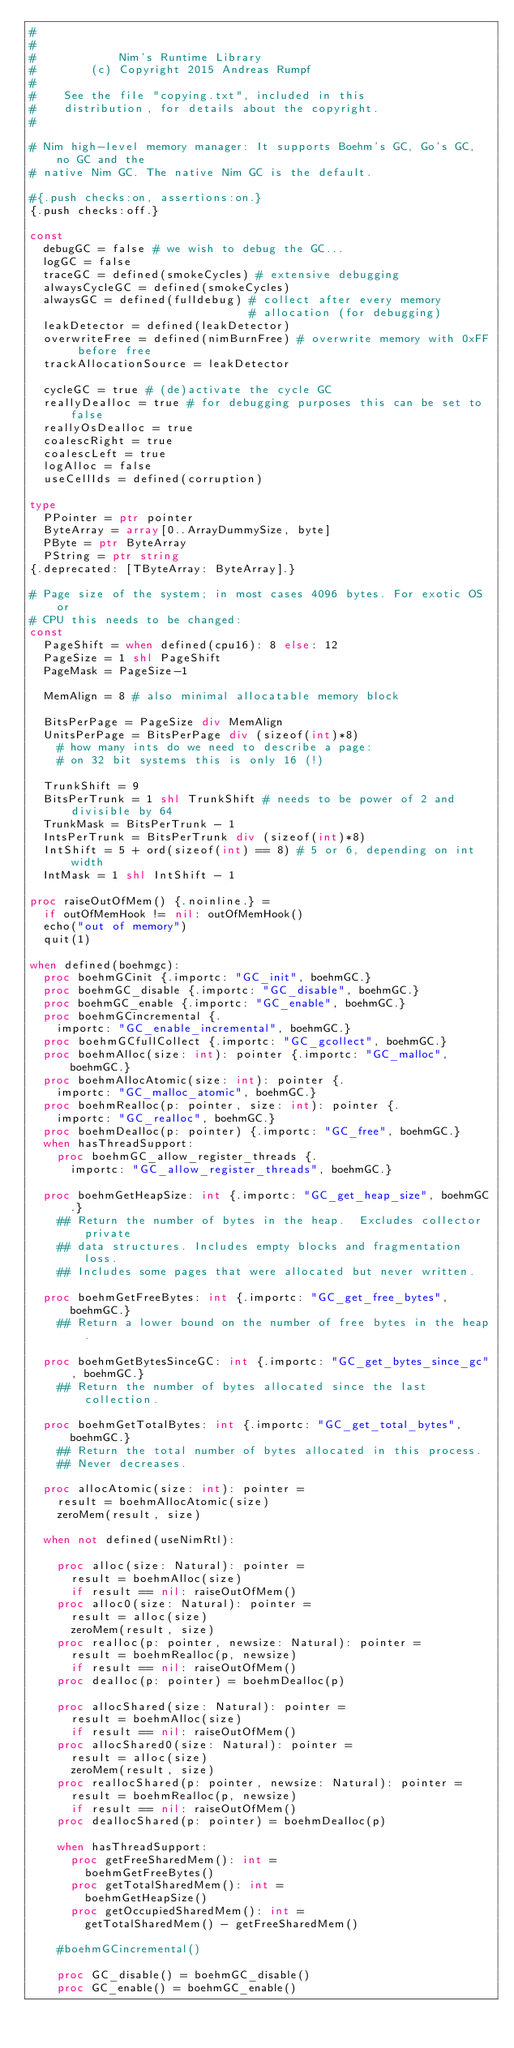Convert code to text. <code><loc_0><loc_0><loc_500><loc_500><_Nim_>#
#
#            Nim's Runtime Library
#        (c) Copyright 2015 Andreas Rumpf
#
#    See the file "copying.txt", included in this
#    distribution, for details about the copyright.
#

# Nim high-level memory manager: It supports Boehm's GC, Go's GC, no GC and the
# native Nim GC. The native Nim GC is the default.

#{.push checks:on, assertions:on.}
{.push checks:off.}

const
  debugGC = false # we wish to debug the GC...
  logGC = false
  traceGC = defined(smokeCycles) # extensive debugging
  alwaysCycleGC = defined(smokeCycles)
  alwaysGC = defined(fulldebug) # collect after every memory
                                # allocation (for debugging)
  leakDetector = defined(leakDetector)
  overwriteFree = defined(nimBurnFree) # overwrite memory with 0xFF before free
  trackAllocationSource = leakDetector

  cycleGC = true # (de)activate the cycle GC
  reallyDealloc = true # for debugging purposes this can be set to false
  reallyOsDealloc = true
  coalescRight = true
  coalescLeft = true
  logAlloc = false
  useCellIds = defined(corruption)

type
  PPointer = ptr pointer
  ByteArray = array[0..ArrayDummySize, byte]
  PByte = ptr ByteArray
  PString = ptr string
{.deprecated: [TByteArray: ByteArray].}

# Page size of the system; in most cases 4096 bytes. For exotic OS or
# CPU this needs to be changed:
const
  PageShift = when defined(cpu16): 8 else: 12
  PageSize = 1 shl PageShift
  PageMask = PageSize-1

  MemAlign = 8 # also minimal allocatable memory block

  BitsPerPage = PageSize div MemAlign
  UnitsPerPage = BitsPerPage div (sizeof(int)*8)
    # how many ints do we need to describe a page:
    # on 32 bit systems this is only 16 (!)

  TrunkShift = 9
  BitsPerTrunk = 1 shl TrunkShift # needs to be power of 2 and divisible by 64
  TrunkMask = BitsPerTrunk - 1
  IntsPerTrunk = BitsPerTrunk div (sizeof(int)*8)
  IntShift = 5 + ord(sizeof(int) == 8) # 5 or 6, depending on int width
  IntMask = 1 shl IntShift - 1

proc raiseOutOfMem() {.noinline.} =
  if outOfMemHook != nil: outOfMemHook()
  echo("out of memory")
  quit(1)

when defined(boehmgc):
  proc boehmGCinit {.importc: "GC_init", boehmGC.}
  proc boehmGC_disable {.importc: "GC_disable", boehmGC.}
  proc boehmGC_enable {.importc: "GC_enable", boehmGC.}
  proc boehmGCincremental {.
    importc: "GC_enable_incremental", boehmGC.}
  proc boehmGCfullCollect {.importc: "GC_gcollect", boehmGC.}
  proc boehmAlloc(size: int): pointer {.importc: "GC_malloc", boehmGC.}
  proc boehmAllocAtomic(size: int): pointer {.
    importc: "GC_malloc_atomic", boehmGC.}
  proc boehmRealloc(p: pointer, size: int): pointer {.
    importc: "GC_realloc", boehmGC.}
  proc boehmDealloc(p: pointer) {.importc: "GC_free", boehmGC.}
  when hasThreadSupport:
    proc boehmGC_allow_register_threads {.
      importc: "GC_allow_register_threads", boehmGC.}

  proc boehmGetHeapSize: int {.importc: "GC_get_heap_size", boehmGC.}
    ## Return the number of bytes in the heap.  Excludes collector private
    ## data structures. Includes empty blocks and fragmentation loss.
    ## Includes some pages that were allocated but never written.

  proc boehmGetFreeBytes: int {.importc: "GC_get_free_bytes", boehmGC.}
    ## Return a lower bound on the number of free bytes in the heap.

  proc boehmGetBytesSinceGC: int {.importc: "GC_get_bytes_since_gc", boehmGC.}
    ## Return the number of bytes allocated since the last collection.

  proc boehmGetTotalBytes: int {.importc: "GC_get_total_bytes", boehmGC.}
    ## Return the total number of bytes allocated in this process.
    ## Never decreases.

  proc allocAtomic(size: int): pointer =
    result = boehmAllocAtomic(size)
    zeroMem(result, size)

  when not defined(useNimRtl):

    proc alloc(size: Natural): pointer =
      result = boehmAlloc(size)
      if result == nil: raiseOutOfMem()
    proc alloc0(size: Natural): pointer =
      result = alloc(size)
      zeroMem(result, size)
    proc realloc(p: pointer, newsize: Natural): pointer =
      result = boehmRealloc(p, newsize)
      if result == nil: raiseOutOfMem()
    proc dealloc(p: pointer) = boehmDealloc(p)

    proc allocShared(size: Natural): pointer =
      result = boehmAlloc(size)
      if result == nil: raiseOutOfMem()
    proc allocShared0(size: Natural): pointer =
      result = alloc(size)
      zeroMem(result, size)
    proc reallocShared(p: pointer, newsize: Natural): pointer =
      result = boehmRealloc(p, newsize)
      if result == nil: raiseOutOfMem()
    proc deallocShared(p: pointer) = boehmDealloc(p)

    when hasThreadSupport:
      proc getFreeSharedMem(): int =
        boehmGetFreeBytes()
      proc getTotalSharedMem(): int =
        boehmGetHeapSize()
      proc getOccupiedSharedMem(): int =
        getTotalSharedMem() - getFreeSharedMem()

    #boehmGCincremental()

    proc GC_disable() = boehmGC_disable()
    proc GC_enable() = boehmGC_enable()</code> 